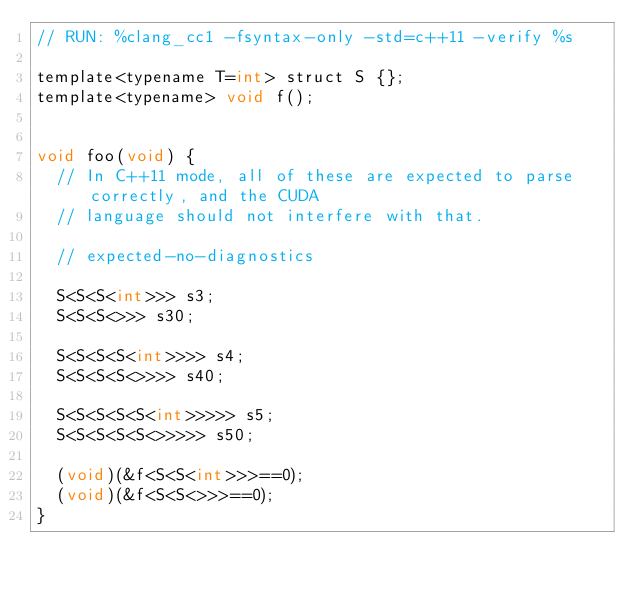<code> <loc_0><loc_0><loc_500><loc_500><_Cuda_>// RUN: %clang_cc1 -fsyntax-only -std=c++11 -verify %s

template<typename T=int> struct S {};
template<typename> void f();


void foo(void) {
  // In C++11 mode, all of these are expected to parse correctly, and the CUDA
  // language should not interfere with that.

  // expected-no-diagnostics

  S<S<S<int>>> s3;
  S<S<S<>>> s30;

  S<S<S<S<int>>>> s4;
  S<S<S<S<>>>> s40;

  S<S<S<S<S<int>>>>> s5;
  S<S<S<S<S<>>>>> s50;

  (void)(&f<S<S<int>>>==0);
  (void)(&f<S<S<>>>==0);
}
</code> 